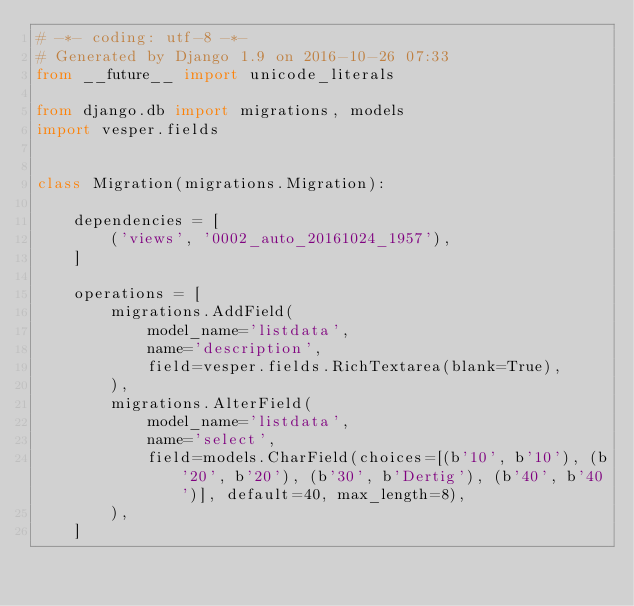Convert code to text. <code><loc_0><loc_0><loc_500><loc_500><_Python_># -*- coding: utf-8 -*-
# Generated by Django 1.9 on 2016-10-26 07:33
from __future__ import unicode_literals

from django.db import migrations, models
import vesper.fields


class Migration(migrations.Migration):

    dependencies = [
        ('views', '0002_auto_20161024_1957'),
    ]

    operations = [
        migrations.AddField(
            model_name='listdata',
            name='description',
            field=vesper.fields.RichTextarea(blank=True),
        ),
        migrations.AlterField(
            model_name='listdata',
            name='select',
            field=models.CharField(choices=[(b'10', b'10'), (b'20', b'20'), (b'30', b'Dertig'), (b'40', b'40')], default=40, max_length=8),
        ),
    ]
</code> 